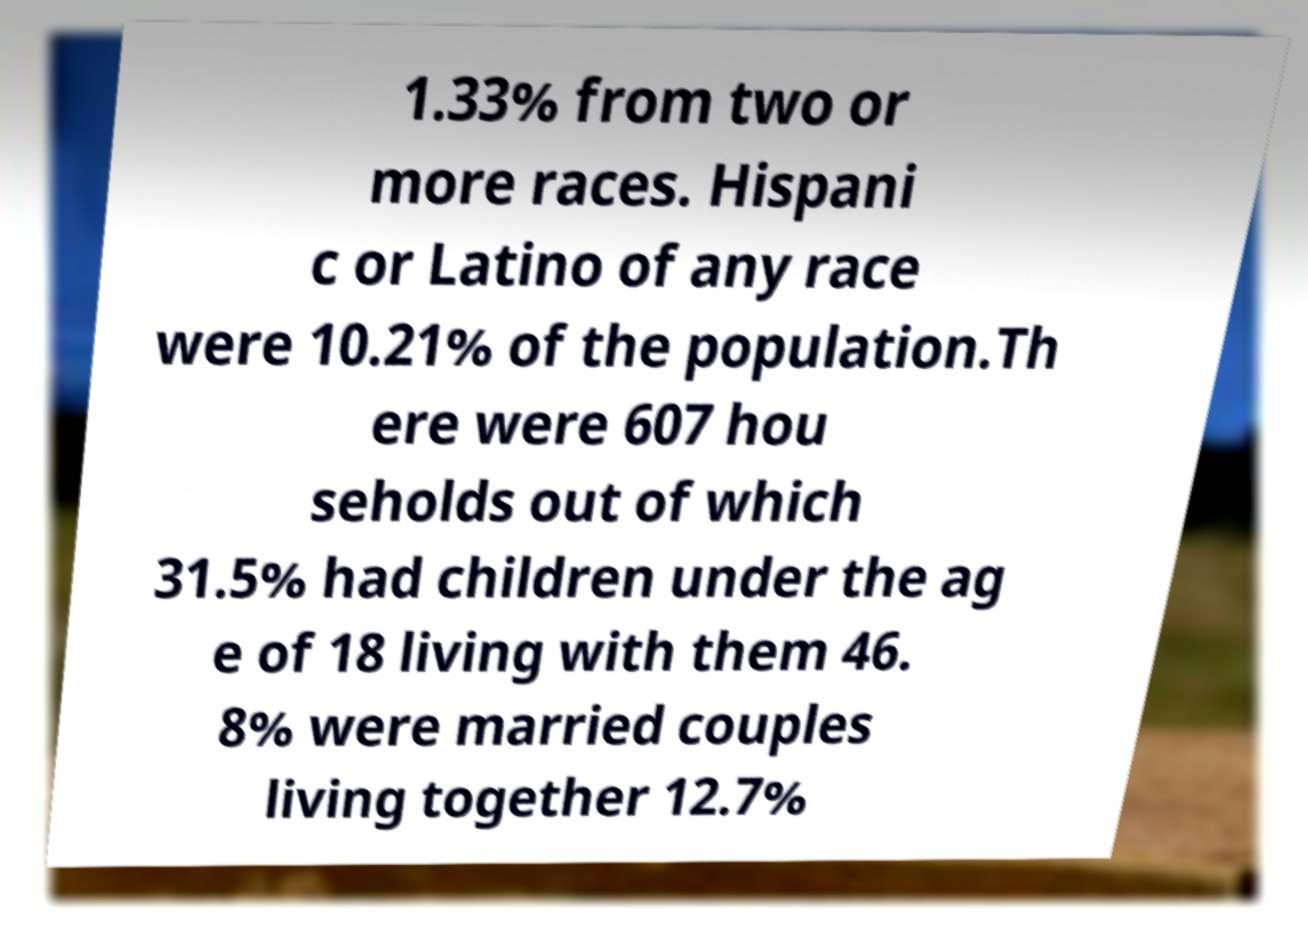What messages or text are displayed in this image? I need them in a readable, typed format. 1.33% from two or more races. Hispani c or Latino of any race were 10.21% of the population.Th ere were 607 hou seholds out of which 31.5% had children under the ag e of 18 living with them 46. 8% were married couples living together 12.7% 